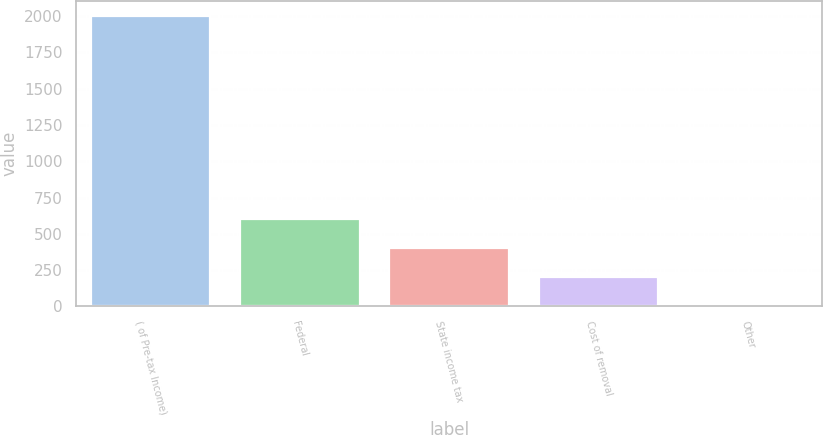<chart> <loc_0><loc_0><loc_500><loc_500><bar_chart><fcel>( of Pre-tax Income)<fcel>Federal<fcel>State income tax<fcel>Cost of removal<fcel>Other<nl><fcel>2003<fcel>601.6<fcel>401.4<fcel>201.2<fcel>1<nl></chart> 